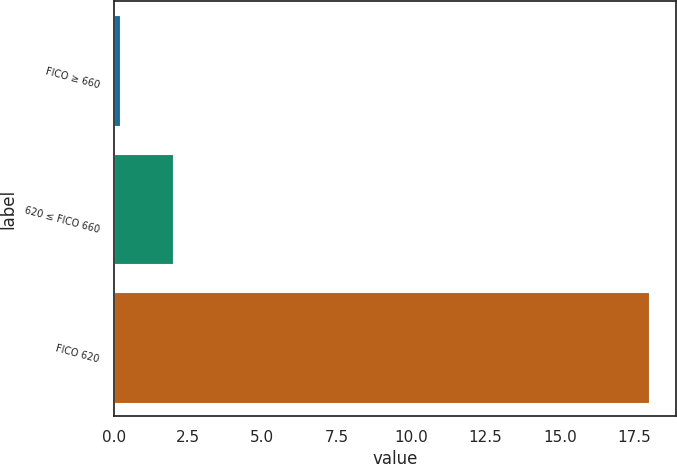Convert chart to OTSL. <chart><loc_0><loc_0><loc_500><loc_500><bar_chart><fcel>FICO ≥ 660<fcel>620 ≤ FICO 660<fcel>FICO 620<nl><fcel>0.2<fcel>1.98<fcel>18<nl></chart> 